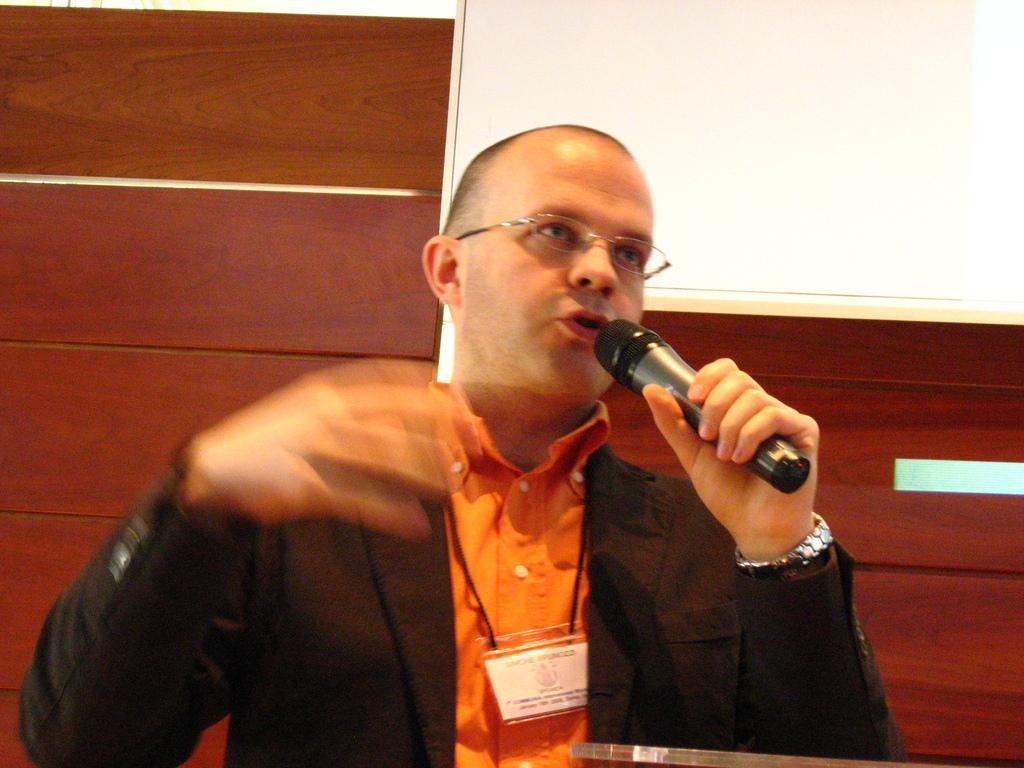Who is present in the image? There is a man in the image. What is the man wearing? The man is wearing clothes, a wrist watch, and spectacles. What is the man holding in the image? The man is holding a microphone. What can be seen behind the man in the image? There is a white board and a wooden wall in the image. What type of jewel is the man wearing on his neck in the image? There is no jewel visible around the man's neck in the image. What type of juice is the man holding in the image? The man is holding a microphone, not a juice, in the image. 